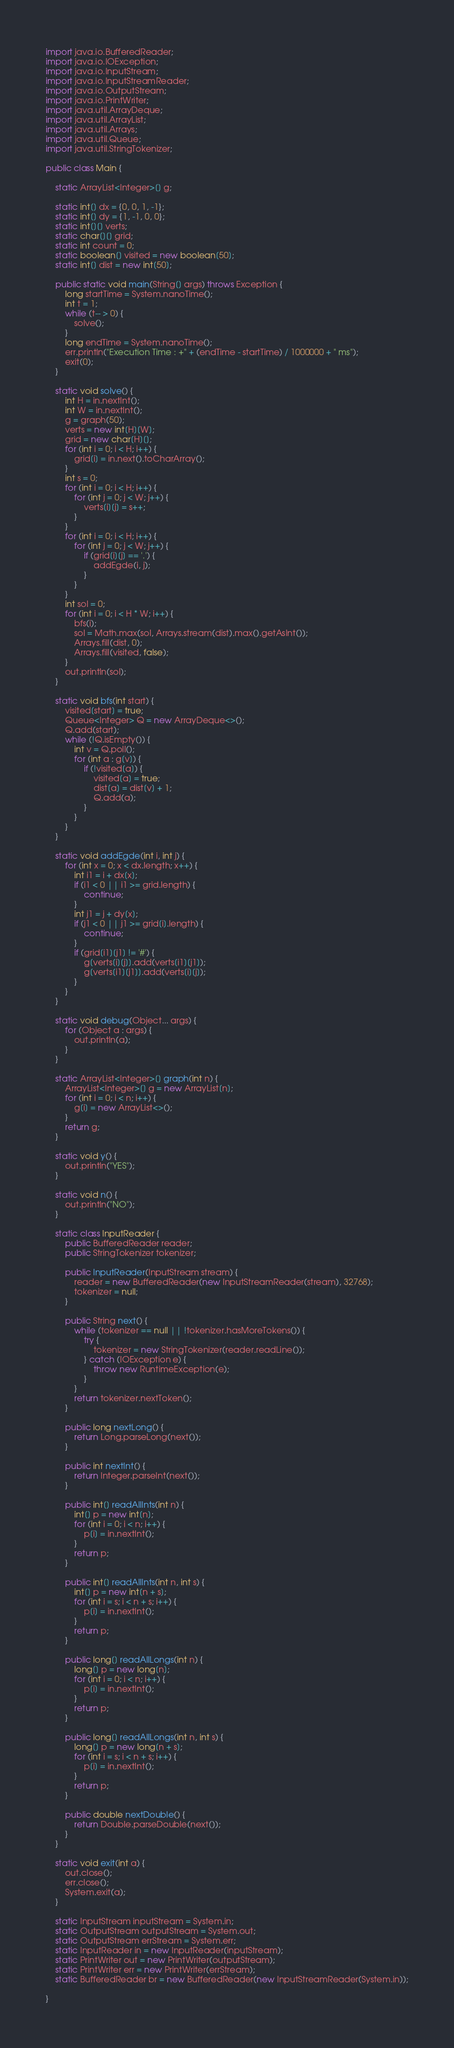<code> <loc_0><loc_0><loc_500><loc_500><_Java_>import java.io.BufferedReader;
import java.io.IOException;
import java.io.InputStream;
import java.io.InputStreamReader;
import java.io.OutputStream;
import java.io.PrintWriter;
import java.util.ArrayDeque;
import java.util.ArrayList;
import java.util.Arrays;
import java.util.Queue;
import java.util.StringTokenizer;

public class Main {

    static ArrayList<Integer>[] g;

    static int[] dx = {0, 0, 1, -1};
    static int[] dy = {1, -1, 0, 0};
    static int[][] verts;
    static char[][] grid;
    static int count = 0;
    static boolean[] visited = new boolean[50];
    static int[] dist = new int[50];

    public static void main(String[] args) throws Exception {
        long startTime = System.nanoTime();
        int t = 1;
        while (t-- > 0) {
            solve();
        }
        long endTime = System.nanoTime();
        err.println("Execution Time : +" + (endTime - startTime) / 1000000 + " ms");
        exit(0);
    }

    static void solve() {
        int H = in.nextInt();
        int W = in.nextInt();
        g = graph(50);
        verts = new int[H][W];
        grid = new char[H][];
        for (int i = 0; i < H; i++) {
            grid[i] = in.next().toCharArray();
        }
        int s = 0;
        for (int i = 0; i < H; i++) {
            for (int j = 0; j < W; j++) {
                verts[i][j] = s++;
            }
        }
        for (int i = 0; i < H; i++) {
            for (int j = 0; j < W; j++) {
                if (grid[i][j] == '.') {
                    addEgde(i, j);
                }
            }
        }
        int sol = 0;
        for (int i = 0; i < H * W; i++) {
            bfs(i);
            sol = Math.max(sol, Arrays.stream(dist).max().getAsInt());
            Arrays.fill(dist, 0);
            Arrays.fill(visited, false);
        }
        out.println(sol);
    }

    static void bfs(int start) {
        visited[start] = true;
        Queue<Integer> Q = new ArrayDeque<>();
        Q.add(start);
        while (!Q.isEmpty()) {
            int v = Q.poll();
            for (int a : g[v]) {
                if (!visited[a]) {
                    visited[a] = true;
                    dist[a] = dist[v] + 1;
                    Q.add(a);
                }
            }
        }
    }

    static void addEgde(int i, int j) {
        for (int x = 0; x < dx.length; x++) {
            int i1 = i + dx[x];
            if (i1 < 0 || i1 >= grid.length) {
                continue;
            }
            int j1 = j + dy[x];
            if (j1 < 0 || j1 >= grid[i].length) {
                continue;
            }
            if (grid[i1][j1] != '#') {
                g[verts[i][j]].add(verts[i1][j1]);
                g[verts[i1][j1]].add(verts[i][j]);
            }
        }
    }

    static void debug(Object... args) {
        for (Object a : args) {
            out.println(a);
        }
    }

    static ArrayList<Integer>[] graph(int n) {
        ArrayList<Integer>[] g = new ArrayList[n];
        for (int i = 0; i < n; i++) {
            g[i] = new ArrayList<>();
        }
        return g;
    }

    static void y() {
        out.println("YES");
    }

    static void n() {
        out.println("NO");
    }

    static class InputReader {
        public BufferedReader reader;
        public StringTokenizer tokenizer;

        public InputReader(InputStream stream) {
            reader = new BufferedReader(new InputStreamReader(stream), 32768);
            tokenizer = null;
        }

        public String next() {
            while (tokenizer == null || !tokenizer.hasMoreTokens()) {
                try {
                    tokenizer = new StringTokenizer(reader.readLine());
                } catch (IOException e) {
                    throw new RuntimeException(e);
                }
            }
            return tokenizer.nextToken();
        }

        public long nextLong() {
            return Long.parseLong(next());
        }

        public int nextInt() {
            return Integer.parseInt(next());
        }

        public int[] readAllInts(int n) {
            int[] p = new int[n];
            for (int i = 0; i < n; i++) {
                p[i] = in.nextInt();
            }
            return p;
        }

        public int[] readAllInts(int n, int s) {
            int[] p = new int[n + s];
            for (int i = s; i < n + s; i++) {
                p[i] = in.nextInt();
            }
            return p;
        }

        public long[] readAllLongs(int n) {
            long[] p = new long[n];
            for (int i = 0; i < n; i++) {
                p[i] = in.nextInt();
            }
            return p;
        }

        public long[] readAllLongs(int n, int s) {
            long[] p = new long[n + s];
            for (int i = s; i < n + s; i++) {
                p[i] = in.nextInt();
            }
            return p;
        }

        public double nextDouble() {
            return Double.parseDouble(next());
        }
    }

    static void exit(int a) {
        out.close();
        err.close();
        System.exit(a);
    }

    static InputStream inputStream = System.in;
    static OutputStream outputStream = System.out;
    static OutputStream errStream = System.err;
    static InputReader in = new InputReader(inputStream);
    static PrintWriter out = new PrintWriter(outputStream);
    static PrintWriter err = new PrintWriter(errStream);
    static BufferedReader br = new BufferedReader(new InputStreamReader(System.in));

}
</code> 